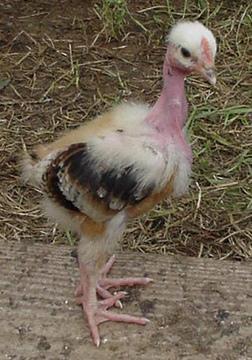How many different colors are the animals in the picture?
Give a very brief answer. 3. How many people are wearing glasses?
Give a very brief answer. 0. 